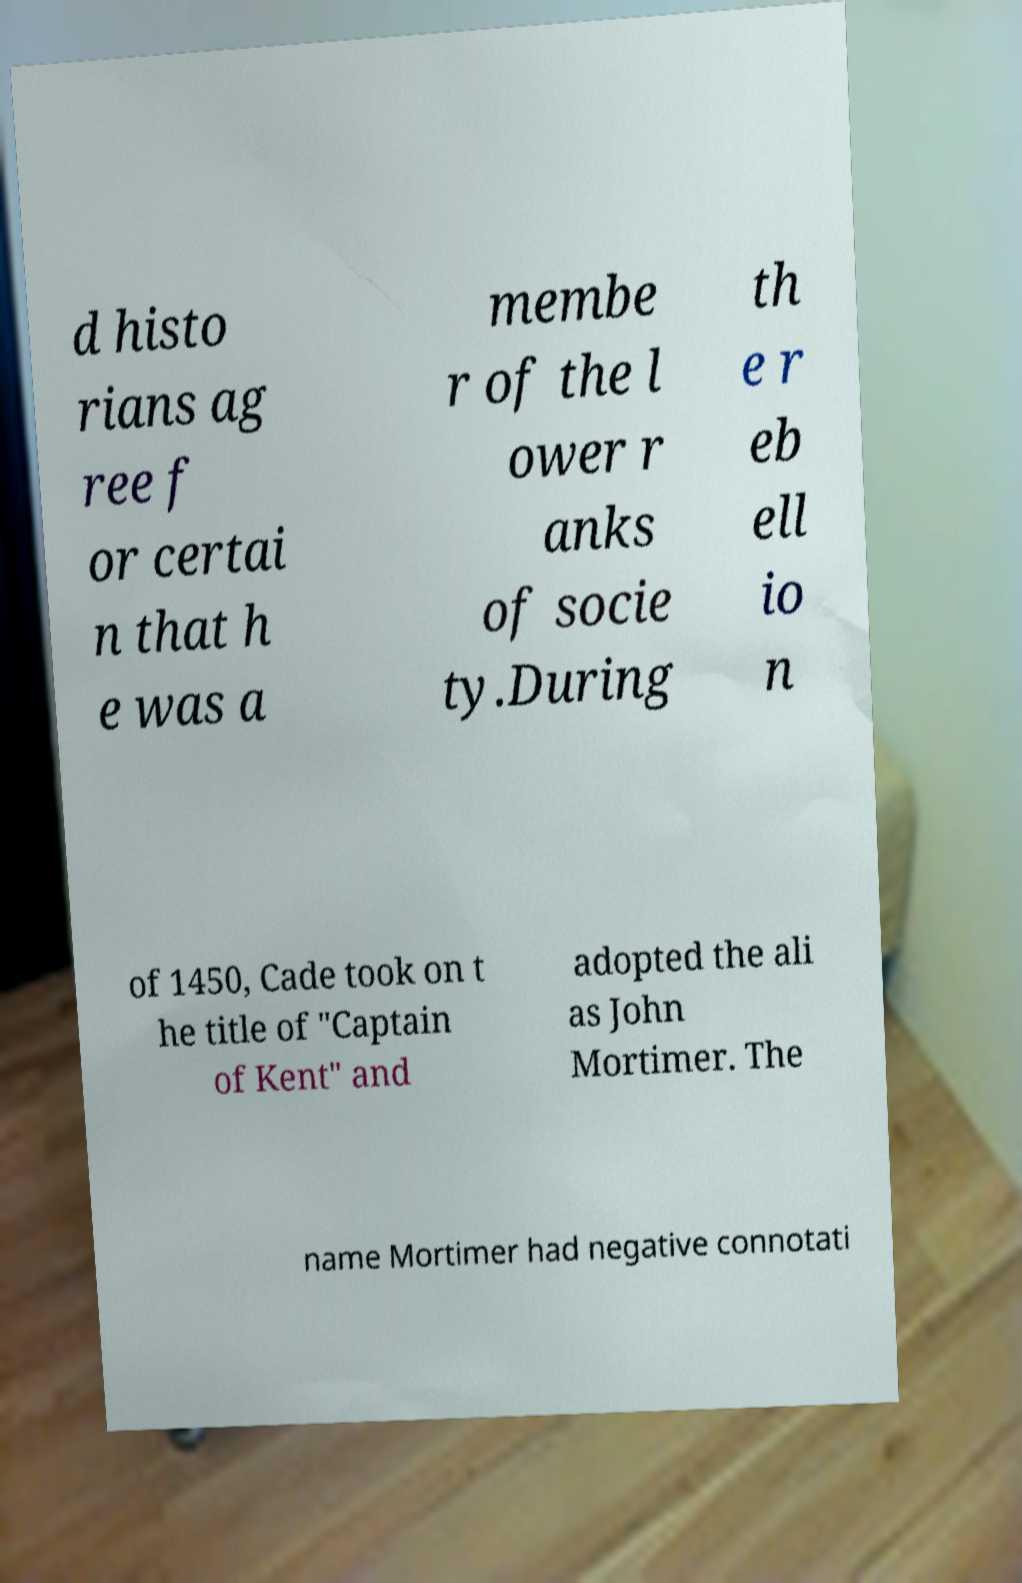Please identify and transcribe the text found in this image. d histo rians ag ree f or certai n that h e was a membe r of the l ower r anks of socie ty.During th e r eb ell io n of 1450, Cade took on t he title of "Captain of Kent" and adopted the ali as John Mortimer. The name Mortimer had negative connotati 